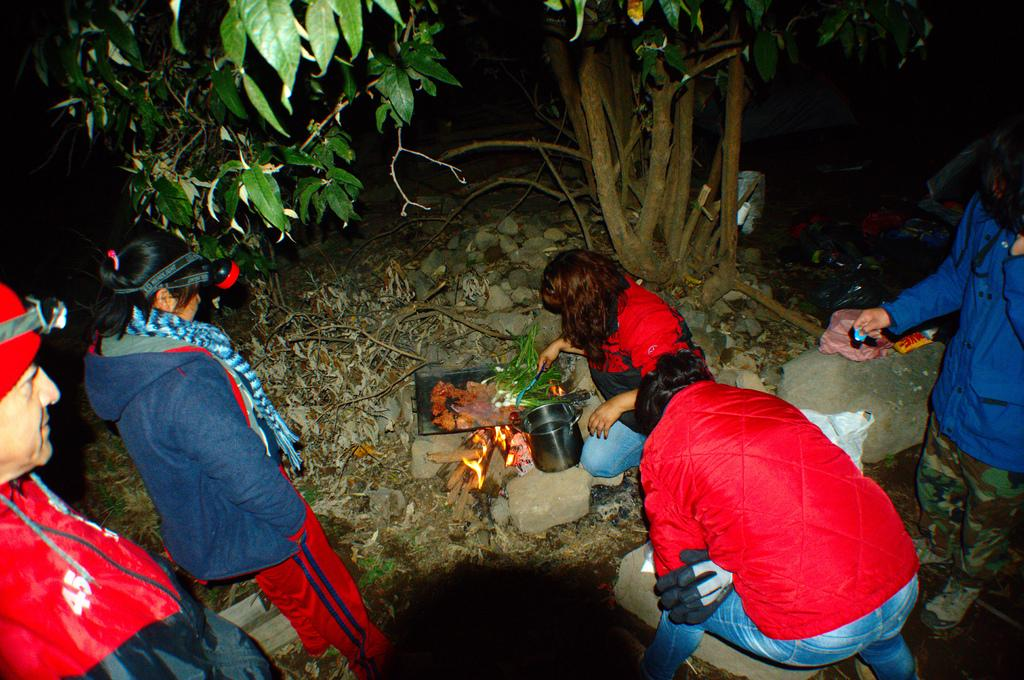How many people are in the image? There is a group of people in the image. What is one person in the group doing? One person is sitting and holding an object. What can be used for eating in the image? There are utensils visible in the image. What is the source of heat in the image? There is fire in the image. What is being prepared or consumed in the image? There is food in the image. What type of natural vegetation is present in the image? There are trees in the image. Where is the drawer located in the image? There is no drawer present in the image. Can you describe the garden in the image? There is no garden present in the image. 